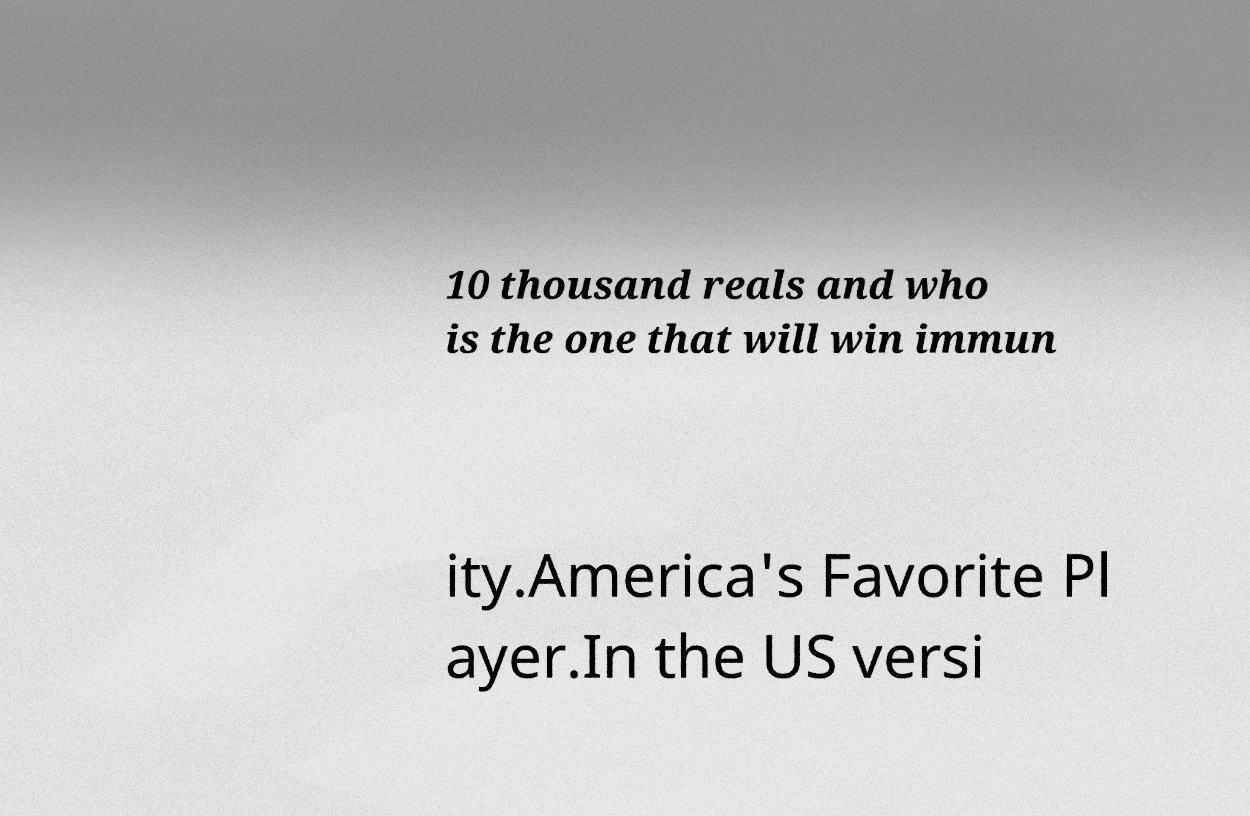For documentation purposes, I need the text within this image transcribed. Could you provide that? 10 thousand reals and who is the one that will win immun ity.America's Favorite Pl ayer.In the US versi 